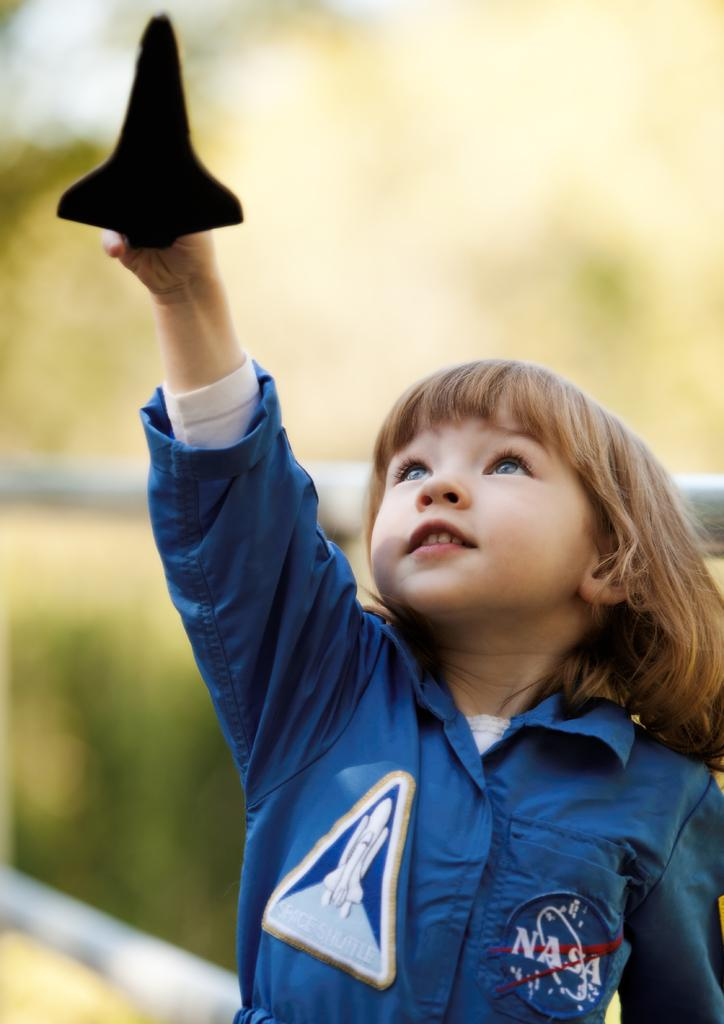<image>
Write a terse but informative summary of the picture. A small child wearing a blue NASA jump suit points a model of a space shuttle towards the sky. 